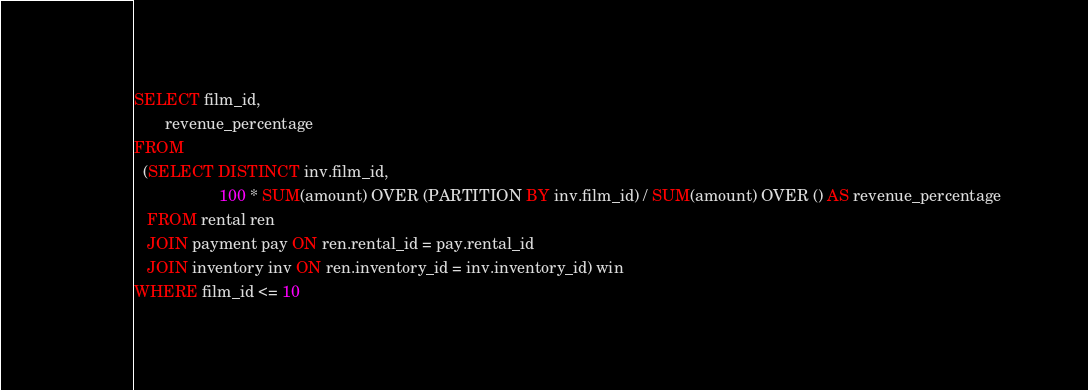<code> <loc_0><loc_0><loc_500><loc_500><_SQL_>SELECT film_id,
       revenue_percentage
FROM
  (SELECT DISTINCT inv.film_id,
                   100 * SUM(amount) OVER (PARTITION BY inv.film_id) / SUM(amount) OVER () AS revenue_percentage
   FROM rental ren
   JOIN payment pay ON ren.rental_id = pay.rental_id
   JOIN inventory inv ON ren.inventory_id = inv.inventory_id) win
WHERE film_id <= 10</code> 